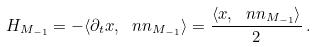<formula> <loc_0><loc_0><loc_500><loc_500>H _ { M _ { - 1 } } = - \langle \partial _ { t } x , \ n n _ { M _ { - 1 } } \rangle = \frac { \langle x , \ n n _ { M _ { - 1 } } \rangle } { 2 } \, .</formula> 